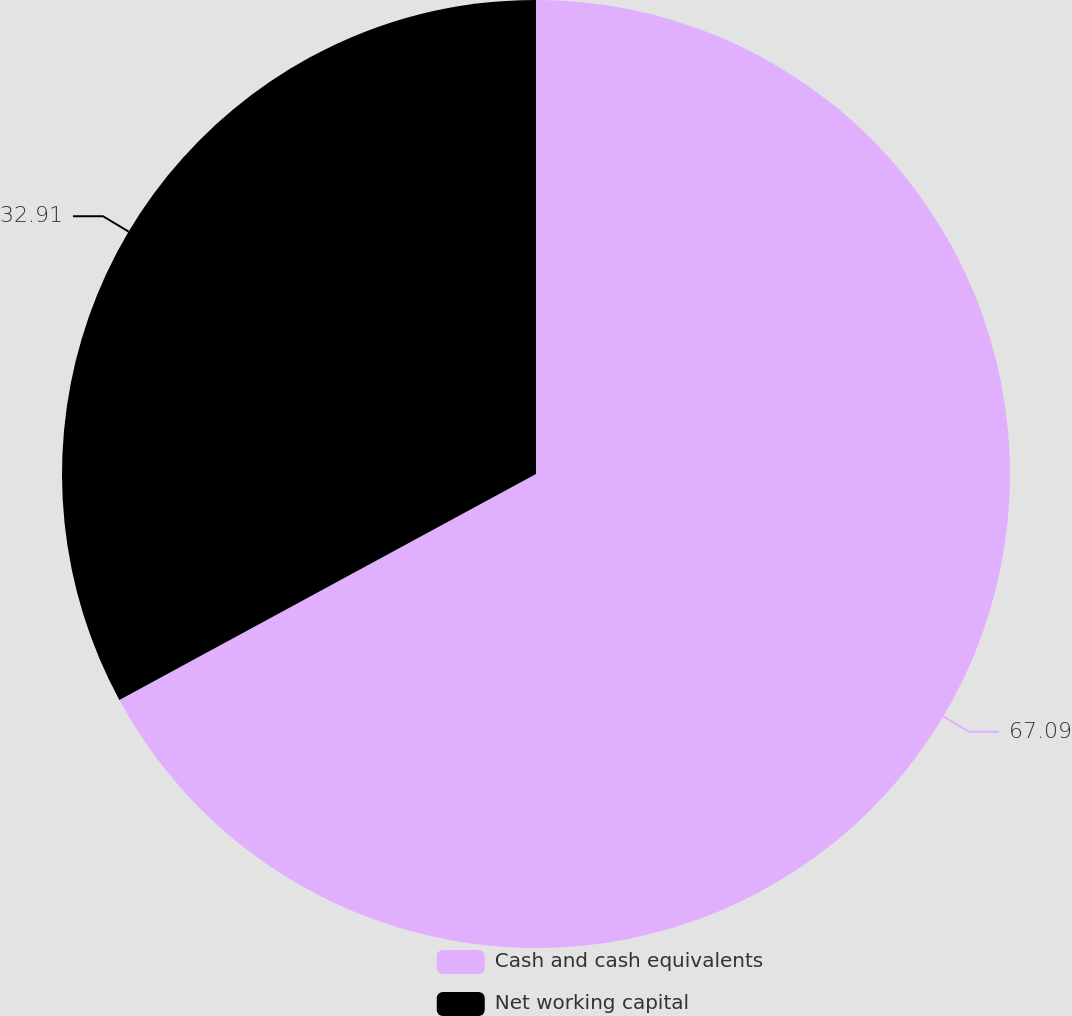Convert chart. <chart><loc_0><loc_0><loc_500><loc_500><pie_chart><fcel>Cash and cash equivalents<fcel>Net working capital<nl><fcel>67.09%<fcel>32.91%<nl></chart> 